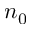<formula> <loc_0><loc_0><loc_500><loc_500>n _ { 0 }</formula> 